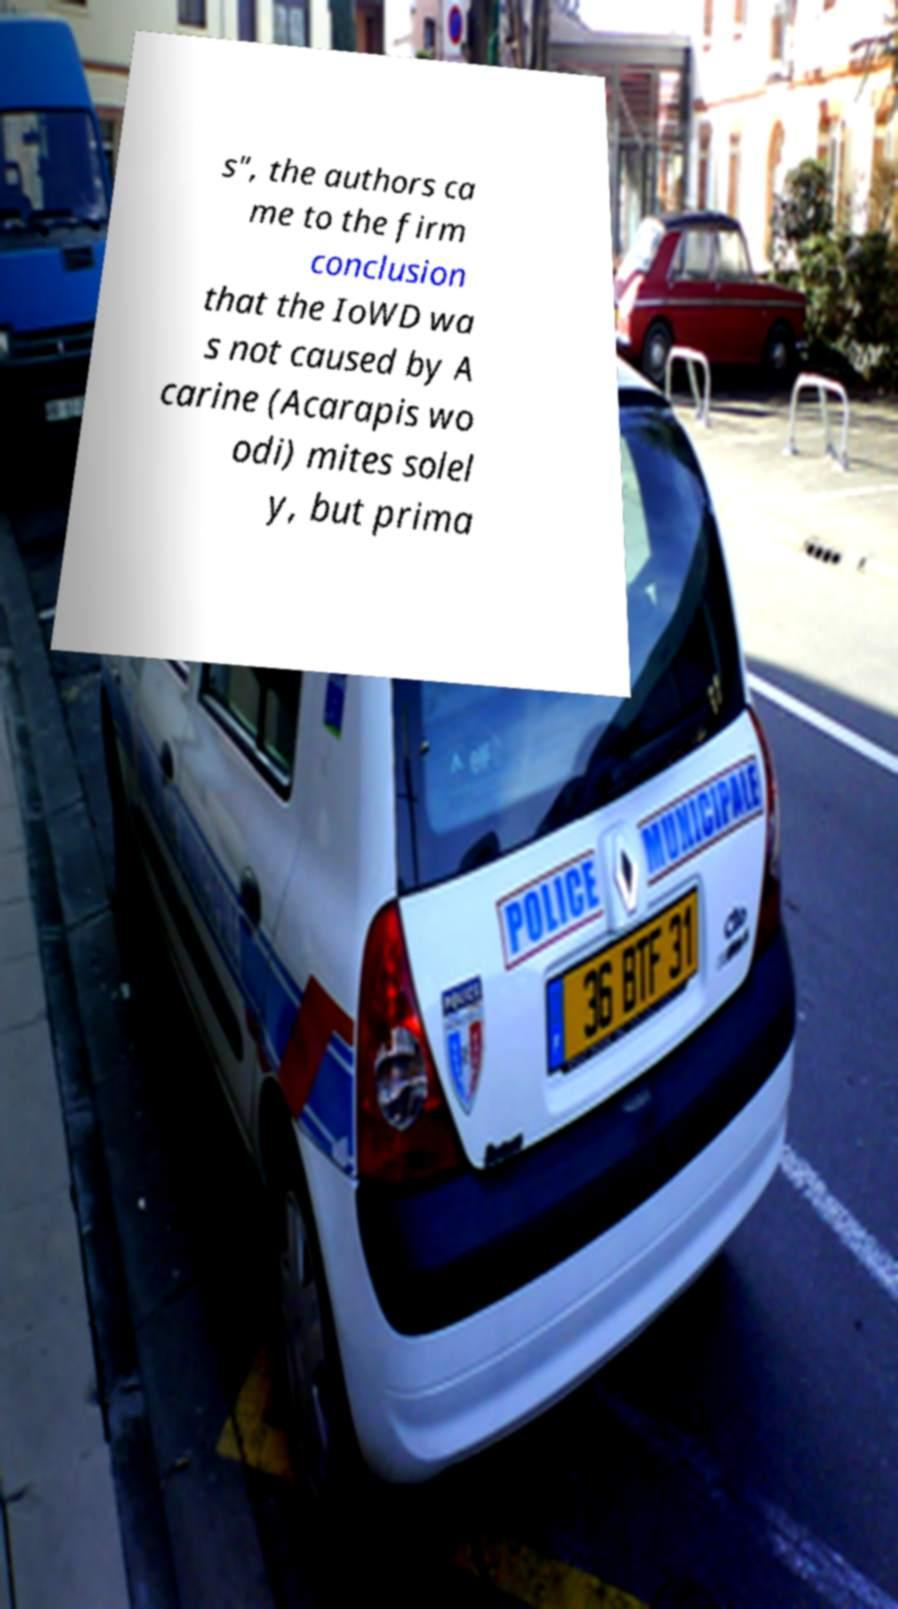Please identify and transcribe the text found in this image. s", the authors ca me to the firm conclusion that the IoWD wa s not caused by A carine (Acarapis wo odi) mites solel y, but prima 